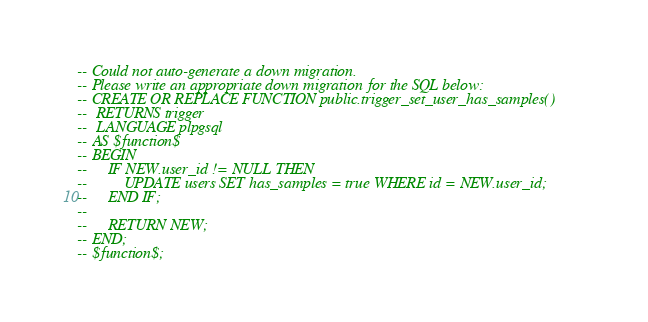<code> <loc_0><loc_0><loc_500><loc_500><_SQL_>-- Could not auto-generate a down migration.
-- Please write an appropriate down migration for the SQL below:
-- CREATE OR REPLACE FUNCTION public.trigger_set_user_has_samples()
--  RETURNS trigger
--  LANGUAGE plpgsql
-- AS $function$
-- BEGIN
--     IF NEW.user_id != NULL THEN
--         UPDATE users SET has_samples = true WHERE id = NEW.user_id;
--     END IF;
--
--     RETURN NEW;
-- END;
-- $function$;
</code> 